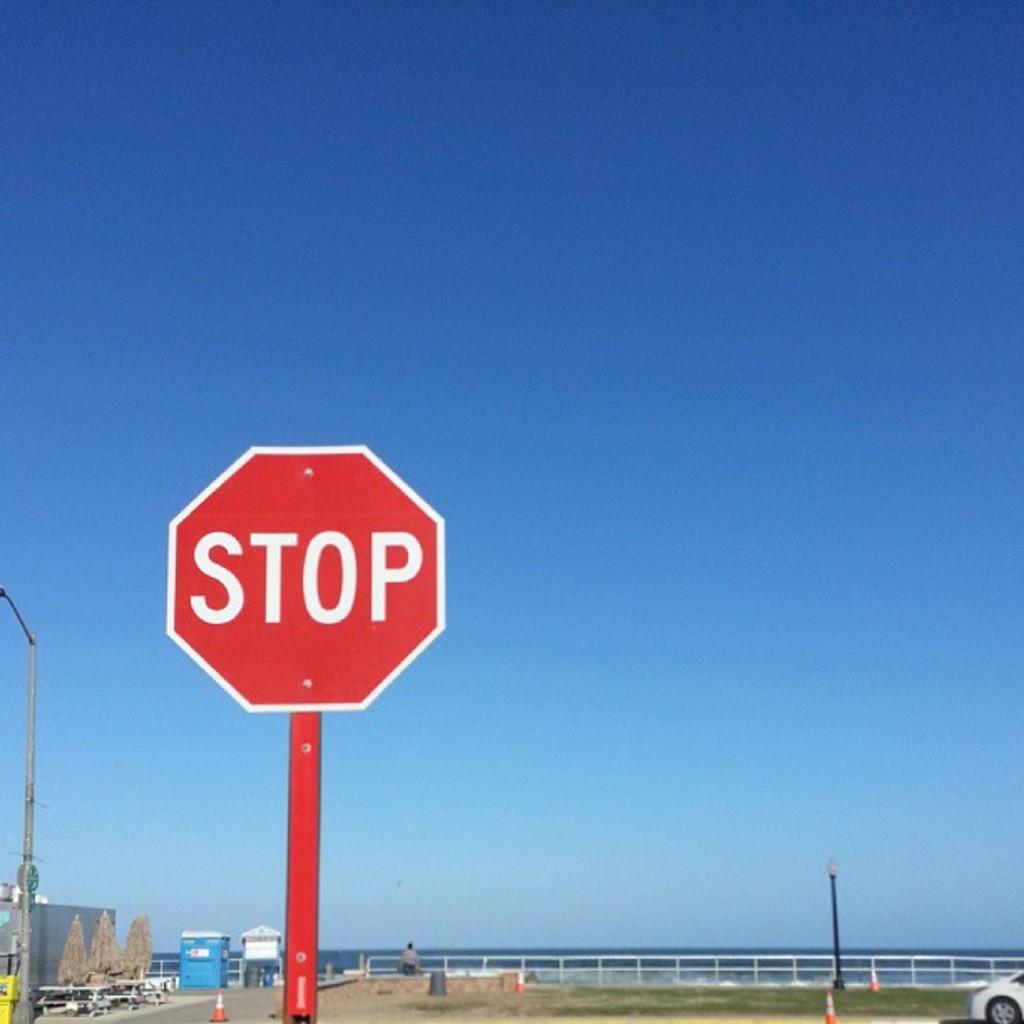What kind of street sign is this?
Ensure brevity in your answer.  Stop. What color is the stop sign?
Ensure brevity in your answer.  Answering does not require reading text in the image. 